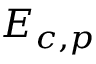Convert formula to latex. <formula><loc_0><loc_0><loc_500><loc_500>{ { E } _ { c , p } }</formula> 